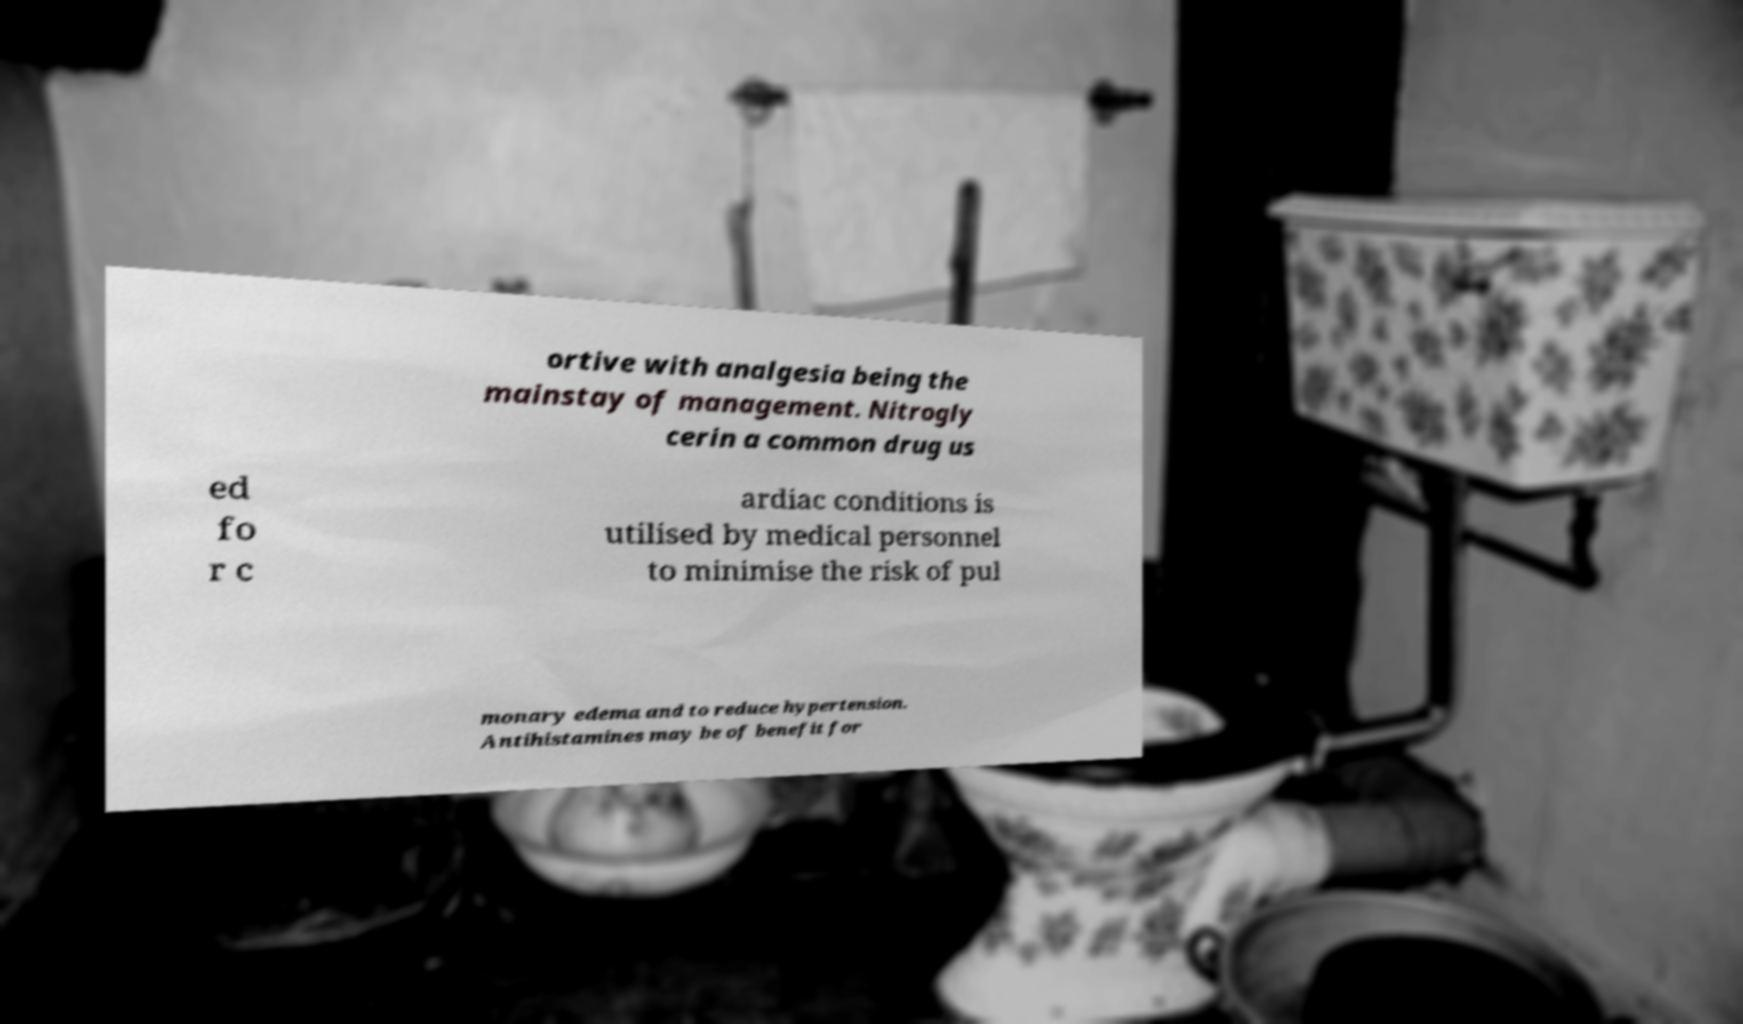I need the written content from this picture converted into text. Can you do that? ortive with analgesia being the mainstay of management. Nitrogly cerin a common drug us ed fo r c ardiac conditions is utilised by medical personnel to minimise the risk of pul monary edema and to reduce hypertension. Antihistamines may be of benefit for 